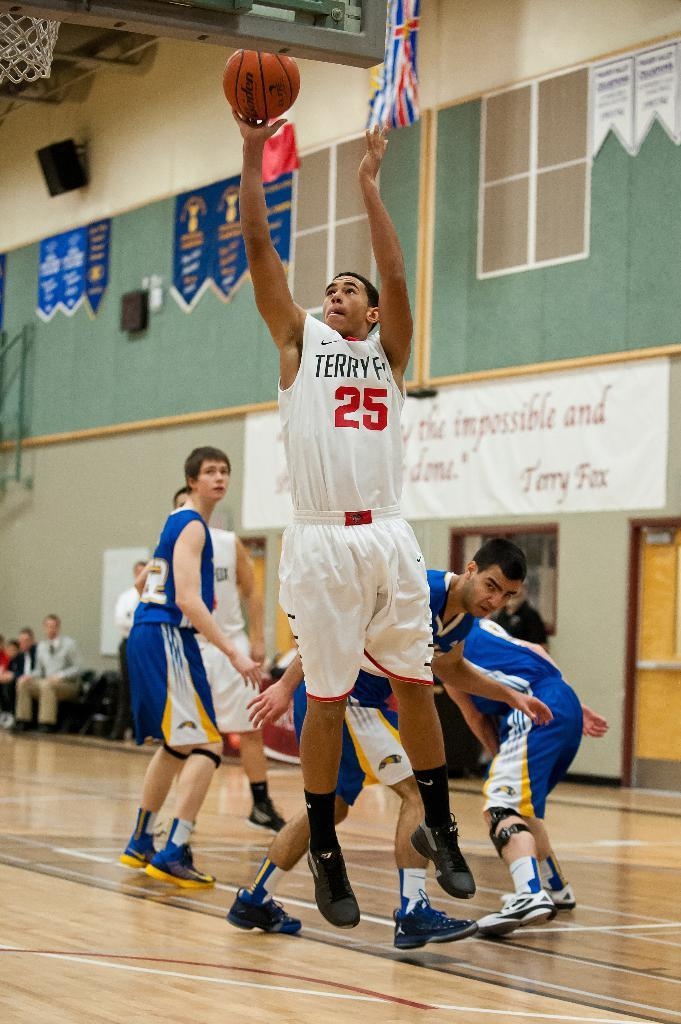What is the man in the image doing? The man is standing and throwing a ball. Can you describe the people in the image? There are people standing and sitting on chairs in the image. What is the structure visible in the image? There is a wall with a window in the image. What type of agreement is being signed on the crib in the image? There is no crib or agreement present in the image. What kind of performance is happening on the stage in the image? There is no stage present in the image. 